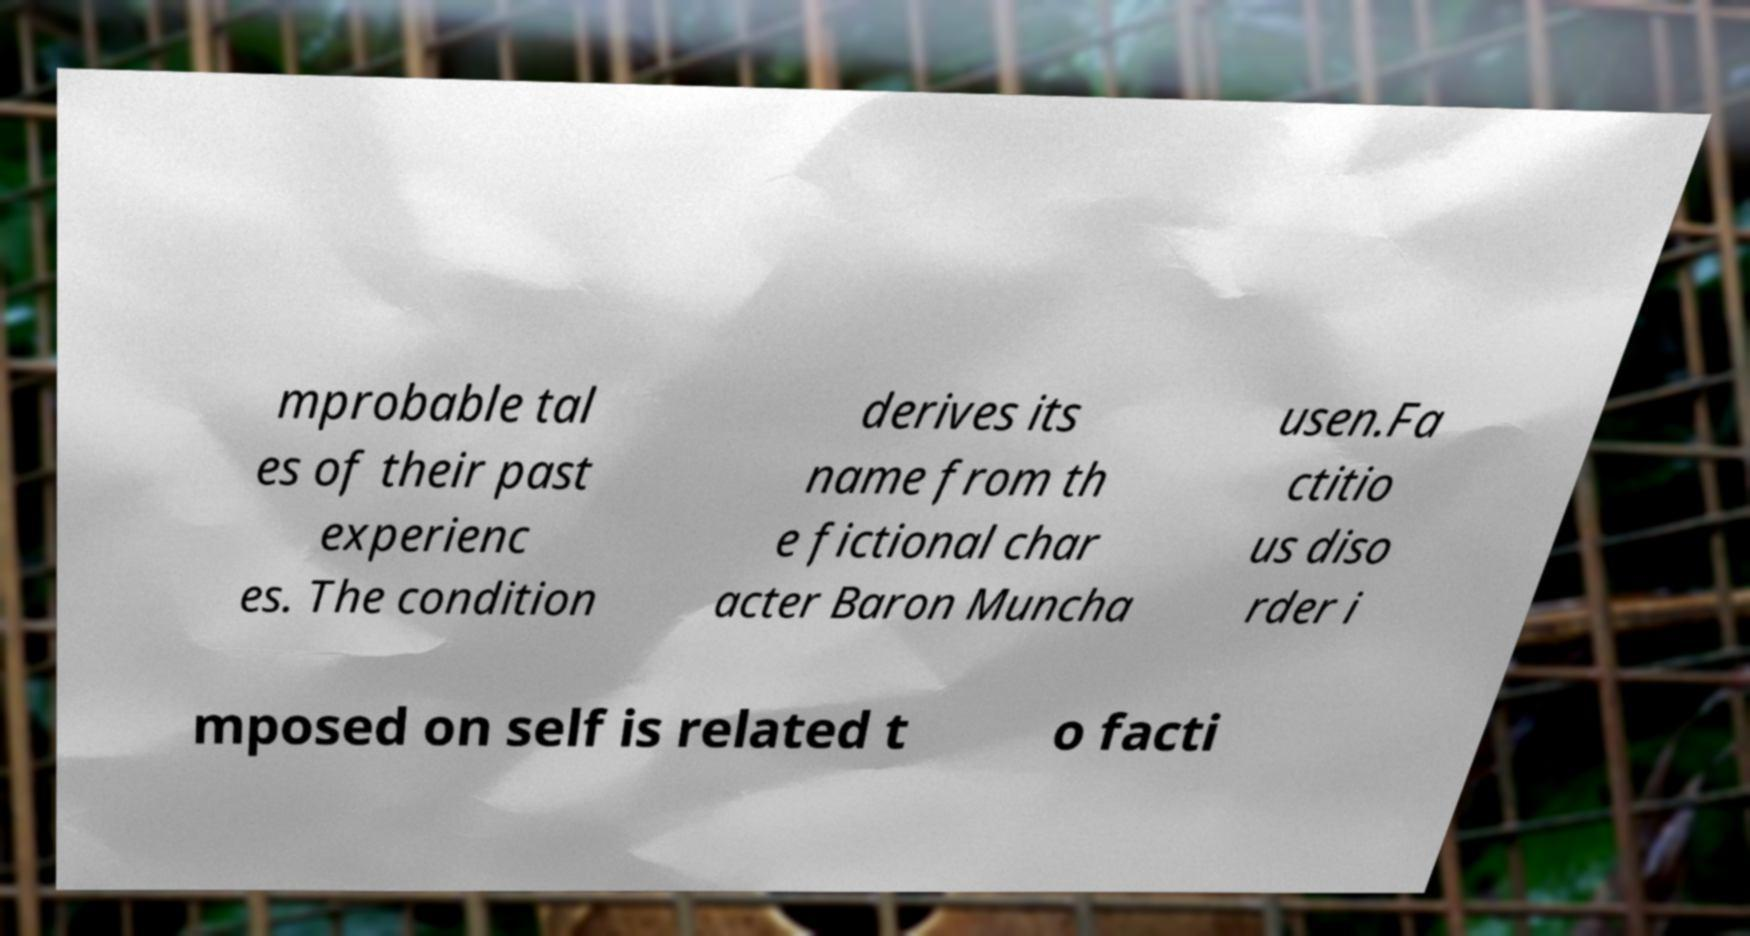Could you assist in decoding the text presented in this image and type it out clearly? mprobable tal es of their past experienc es. The condition derives its name from th e fictional char acter Baron Muncha usen.Fa ctitio us diso rder i mposed on self is related t o facti 